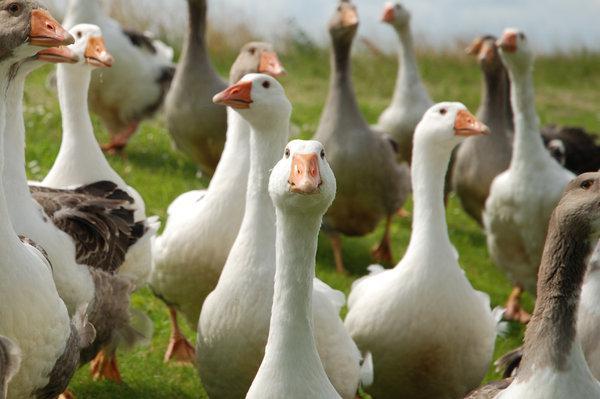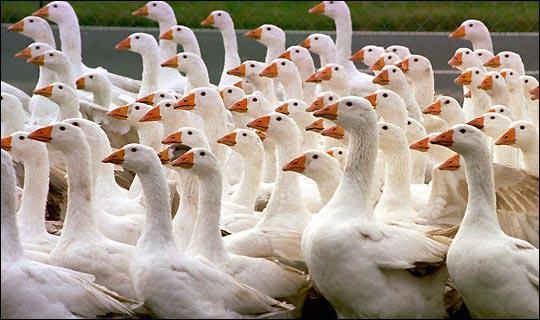The first image is the image on the left, the second image is the image on the right. Assess this claim about the two images: "There are two adult black and brown geese visible". Correct or not? Answer yes or no. No. 